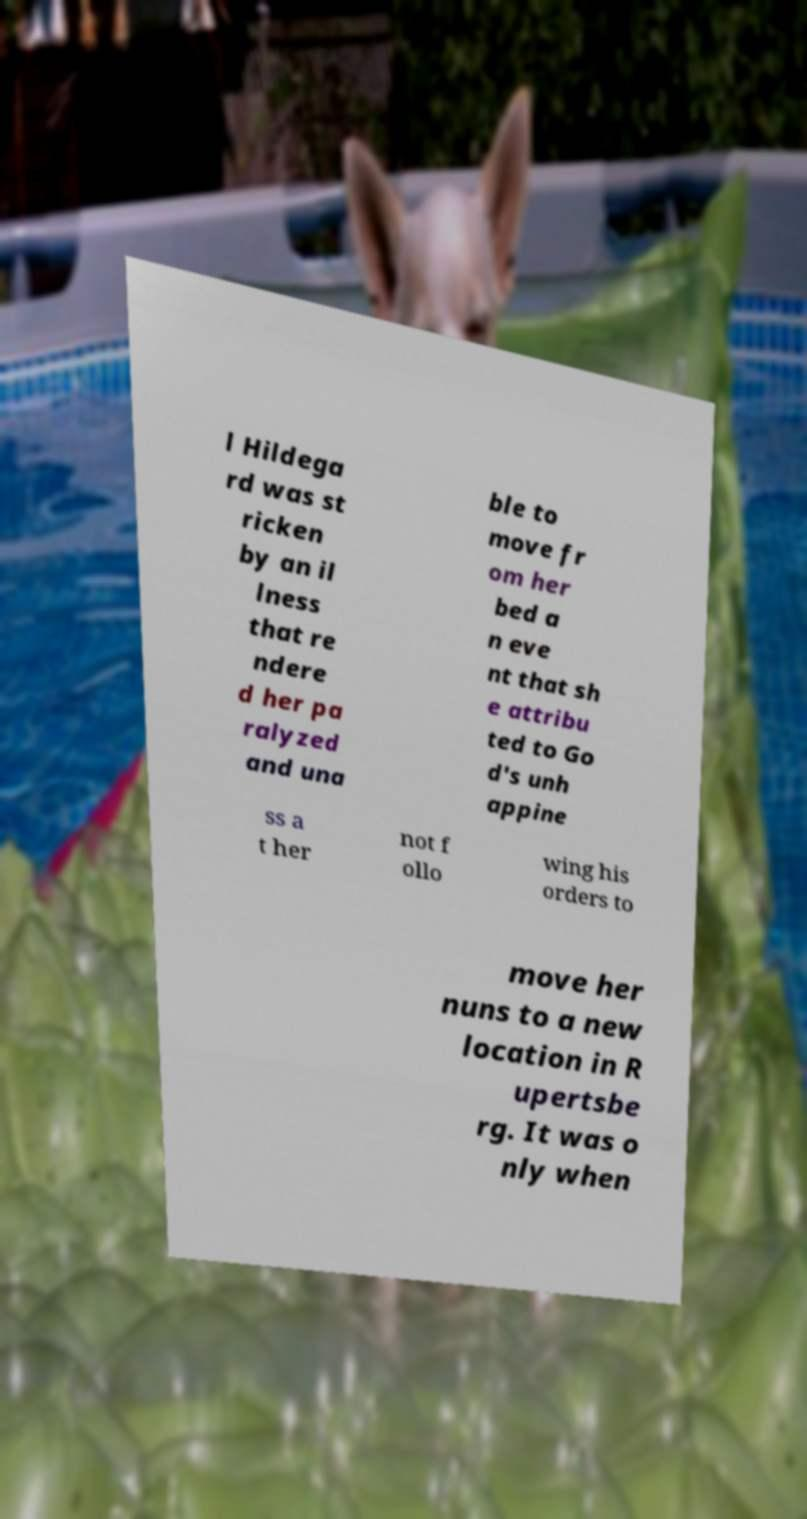For documentation purposes, I need the text within this image transcribed. Could you provide that? l Hildega rd was st ricken by an il lness that re ndere d her pa ralyzed and una ble to move fr om her bed a n eve nt that sh e attribu ted to Go d's unh appine ss a t her not f ollo wing his orders to move her nuns to a new location in R upertsbe rg. It was o nly when 